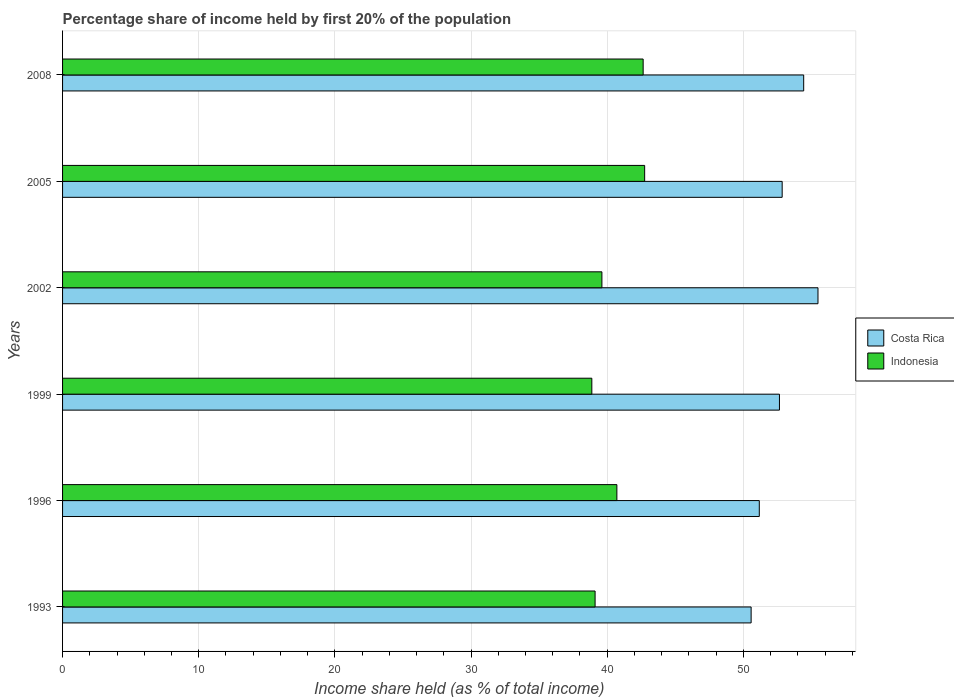How many groups of bars are there?
Provide a succinct answer. 6. Are the number of bars per tick equal to the number of legend labels?
Offer a very short reply. Yes. Are the number of bars on each tick of the Y-axis equal?
Make the answer very short. Yes. What is the label of the 6th group of bars from the top?
Your answer should be very brief. 1993. What is the share of income held by first 20% of the population in Indonesia in 1999?
Offer a very short reply. 38.87. Across all years, what is the maximum share of income held by first 20% of the population in Indonesia?
Ensure brevity in your answer.  42.75. Across all years, what is the minimum share of income held by first 20% of the population in Indonesia?
Offer a terse response. 38.87. In which year was the share of income held by first 20% of the population in Indonesia maximum?
Provide a short and direct response. 2005. In which year was the share of income held by first 20% of the population in Costa Rica minimum?
Keep it short and to the point. 1993. What is the total share of income held by first 20% of the population in Costa Rica in the graph?
Provide a short and direct response. 317.15. What is the difference between the share of income held by first 20% of the population in Indonesia in 1993 and that in 2005?
Ensure brevity in your answer.  -3.64. What is the difference between the share of income held by first 20% of the population in Indonesia in 2008 and the share of income held by first 20% of the population in Costa Rica in 1999?
Provide a succinct answer. -10.01. What is the average share of income held by first 20% of the population in Indonesia per year?
Your response must be concise. 40.62. In the year 1999, what is the difference between the share of income held by first 20% of the population in Indonesia and share of income held by first 20% of the population in Costa Rica?
Ensure brevity in your answer.  -13.78. In how many years, is the share of income held by first 20% of the population in Indonesia greater than 16 %?
Provide a succinct answer. 6. What is the ratio of the share of income held by first 20% of the population in Costa Rica in 1993 to that in 2005?
Offer a terse response. 0.96. Is the share of income held by first 20% of the population in Costa Rica in 2002 less than that in 2005?
Your answer should be compact. No. Is the difference between the share of income held by first 20% of the population in Indonesia in 1999 and 2002 greater than the difference between the share of income held by first 20% of the population in Costa Rica in 1999 and 2002?
Ensure brevity in your answer.  Yes. What is the difference between the highest and the second highest share of income held by first 20% of the population in Indonesia?
Give a very brief answer. 0.11. What is the difference between the highest and the lowest share of income held by first 20% of the population in Costa Rica?
Ensure brevity in your answer.  4.91. What does the 2nd bar from the bottom in 2005 represents?
Provide a short and direct response. Indonesia. How many bars are there?
Offer a very short reply. 12. Are all the bars in the graph horizontal?
Your response must be concise. Yes. Does the graph contain any zero values?
Make the answer very short. No. Does the graph contain grids?
Your response must be concise. Yes. How many legend labels are there?
Make the answer very short. 2. What is the title of the graph?
Offer a terse response. Percentage share of income held by first 20% of the population. Does "Azerbaijan" appear as one of the legend labels in the graph?
Keep it short and to the point. No. What is the label or title of the X-axis?
Keep it short and to the point. Income share held (as % of total income). What is the label or title of the Y-axis?
Offer a terse response. Years. What is the Income share held (as % of total income) in Costa Rica in 1993?
Your response must be concise. 50.57. What is the Income share held (as % of total income) of Indonesia in 1993?
Give a very brief answer. 39.11. What is the Income share held (as % of total income) in Costa Rica in 1996?
Your answer should be very brief. 51.17. What is the Income share held (as % of total income) of Indonesia in 1996?
Your answer should be very brief. 40.71. What is the Income share held (as % of total income) in Costa Rica in 1999?
Your answer should be very brief. 52.65. What is the Income share held (as % of total income) in Indonesia in 1999?
Your answer should be compact. 38.87. What is the Income share held (as % of total income) in Costa Rica in 2002?
Your response must be concise. 55.48. What is the Income share held (as % of total income) of Indonesia in 2002?
Ensure brevity in your answer.  39.61. What is the Income share held (as % of total income) of Costa Rica in 2005?
Make the answer very short. 52.85. What is the Income share held (as % of total income) in Indonesia in 2005?
Your response must be concise. 42.75. What is the Income share held (as % of total income) of Costa Rica in 2008?
Give a very brief answer. 54.43. What is the Income share held (as % of total income) of Indonesia in 2008?
Offer a very short reply. 42.64. Across all years, what is the maximum Income share held (as % of total income) of Costa Rica?
Make the answer very short. 55.48. Across all years, what is the maximum Income share held (as % of total income) in Indonesia?
Your response must be concise. 42.75. Across all years, what is the minimum Income share held (as % of total income) in Costa Rica?
Your answer should be compact. 50.57. Across all years, what is the minimum Income share held (as % of total income) of Indonesia?
Keep it short and to the point. 38.87. What is the total Income share held (as % of total income) of Costa Rica in the graph?
Give a very brief answer. 317.15. What is the total Income share held (as % of total income) in Indonesia in the graph?
Provide a short and direct response. 243.69. What is the difference between the Income share held (as % of total income) in Costa Rica in 1993 and that in 1996?
Your response must be concise. -0.6. What is the difference between the Income share held (as % of total income) in Costa Rica in 1993 and that in 1999?
Offer a terse response. -2.08. What is the difference between the Income share held (as % of total income) of Indonesia in 1993 and that in 1999?
Give a very brief answer. 0.24. What is the difference between the Income share held (as % of total income) in Costa Rica in 1993 and that in 2002?
Give a very brief answer. -4.91. What is the difference between the Income share held (as % of total income) in Indonesia in 1993 and that in 2002?
Give a very brief answer. -0.5. What is the difference between the Income share held (as % of total income) of Costa Rica in 1993 and that in 2005?
Ensure brevity in your answer.  -2.28. What is the difference between the Income share held (as % of total income) in Indonesia in 1993 and that in 2005?
Your answer should be very brief. -3.64. What is the difference between the Income share held (as % of total income) in Costa Rica in 1993 and that in 2008?
Make the answer very short. -3.86. What is the difference between the Income share held (as % of total income) of Indonesia in 1993 and that in 2008?
Provide a short and direct response. -3.53. What is the difference between the Income share held (as % of total income) in Costa Rica in 1996 and that in 1999?
Provide a short and direct response. -1.48. What is the difference between the Income share held (as % of total income) of Indonesia in 1996 and that in 1999?
Your response must be concise. 1.84. What is the difference between the Income share held (as % of total income) in Costa Rica in 1996 and that in 2002?
Give a very brief answer. -4.31. What is the difference between the Income share held (as % of total income) in Costa Rica in 1996 and that in 2005?
Provide a short and direct response. -1.68. What is the difference between the Income share held (as % of total income) of Indonesia in 1996 and that in 2005?
Ensure brevity in your answer.  -2.04. What is the difference between the Income share held (as % of total income) of Costa Rica in 1996 and that in 2008?
Give a very brief answer. -3.26. What is the difference between the Income share held (as % of total income) of Indonesia in 1996 and that in 2008?
Offer a terse response. -1.93. What is the difference between the Income share held (as % of total income) in Costa Rica in 1999 and that in 2002?
Your response must be concise. -2.83. What is the difference between the Income share held (as % of total income) of Indonesia in 1999 and that in 2002?
Offer a very short reply. -0.74. What is the difference between the Income share held (as % of total income) of Costa Rica in 1999 and that in 2005?
Make the answer very short. -0.2. What is the difference between the Income share held (as % of total income) in Indonesia in 1999 and that in 2005?
Make the answer very short. -3.88. What is the difference between the Income share held (as % of total income) of Costa Rica in 1999 and that in 2008?
Offer a very short reply. -1.78. What is the difference between the Income share held (as % of total income) of Indonesia in 1999 and that in 2008?
Give a very brief answer. -3.77. What is the difference between the Income share held (as % of total income) of Costa Rica in 2002 and that in 2005?
Give a very brief answer. 2.63. What is the difference between the Income share held (as % of total income) of Indonesia in 2002 and that in 2005?
Give a very brief answer. -3.14. What is the difference between the Income share held (as % of total income) in Costa Rica in 2002 and that in 2008?
Ensure brevity in your answer.  1.05. What is the difference between the Income share held (as % of total income) in Indonesia in 2002 and that in 2008?
Your answer should be compact. -3.03. What is the difference between the Income share held (as % of total income) of Costa Rica in 2005 and that in 2008?
Provide a succinct answer. -1.58. What is the difference between the Income share held (as % of total income) of Indonesia in 2005 and that in 2008?
Make the answer very short. 0.11. What is the difference between the Income share held (as % of total income) in Costa Rica in 1993 and the Income share held (as % of total income) in Indonesia in 1996?
Your response must be concise. 9.86. What is the difference between the Income share held (as % of total income) in Costa Rica in 1993 and the Income share held (as % of total income) in Indonesia in 2002?
Your answer should be compact. 10.96. What is the difference between the Income share held (as % of total income) in Costa Rica in 1993 and the Income share held (as % of total income) in Indonesia in 2005?
Your response must be concise. 7.82. What is the difference between the Income share held (as % of total income) in Costa Rica in 1993 and the Income share held (as % of total income) in Indonesia in 2008?
Provide a short and direct response. 7.93. What is the difference between the Income share held (as % of total income) of Costa Rica in 1996 and the Income share held (as % of total income) of Indonesia in 1999?
Keep it short and to the point. 12.3. What is the difference between the Income share held (as % of total income) of Costa Rica in 1996 and the Income share held (as % of total income) of Indonesia in 2002?
Make the answer very short. 11.56. What is the difference between the Income share held (as % of total income) of Costa Rica in 1996 and the Income share held (as % of total income) of Indonesia in 2005?
Make the answer very short. 8.42. What is the difference between the Income share held (as % of total income) in Costa Rica in 1996 and the Income share held (as % of total income) in Indonesia in 2008?
Your answer should be compact. 8.53. What is the difference between the Income share held (as % of total income) in Costa Rica in 1999 and the Income share held (as % of total income) in Indonesia in 2002?
Provide a succinct answer. 13.04. What is the difference between the Income share held (as % of total income) in Costa Rica in 1999 and the Income share held (as % of total income) in Indonesia in 2005?
Make the answer very short. 9.9. What is the difference between the Income share held (as % of total income) of Costa Rica in 1999 and the Income share held (as % of total income) of Indonesia in 2008?
Offer a terse response. 10.01. What is the difference between the Income share held (as % of total income) of Costa Rica in 2002 and the Income share held (as % of total income) of Indonesia in 2005?
Offer a very short reply. 12.73. What is the difference between the Income share held (as % of total income) in Costa Rica in 2002 and the Income share held (as % of total income) in Indonesia in 2008?
Keep it short and to the point. 12.84. What is the difference between the Income share held (as % of total income) of Costa Rica in 2005 and the Income share held (as % of total income) of Indonesia in 2008?
Keep it short and to the point. 10.21. What is the average Income share held (as % of total income) of Costa Rica per year?
Your response must be concise. 52.86. What is the average Income share held (as % of total income) of Indonesia per year?
Your response must be concise. 40.62. In the year 1993, what is the difference between the Income share held (as % of total income) of Costa Rica and Income share held (as % of total income) of Indonesia?
Your answer should be compact. 11.46. In the year 1996, what is the difference between the Income share held (as % of total income) in Costa Rica and Income share held (as % of total income) in Indonesia?
Offer a terse response. 10.46. In the year 1999, what is the difference between the Income share held (as % of total income) of Costa Rica and Income share held (as % of total income) of Indonesia?
Give a very brief answer. 13.78. In the year 2002, what is the difference between the Income share held (as % of total income) in Costa Rica and Income share held (as % of total income) in Indonesia?
Provide a short and direct response. 15.87. In the year 2005, what is the difference between the Income share held (as % of total income) of Costa Rica and Income share held (as % of total income) of Indonesia?
Give a very brief answer. 10.1. In the year 2008, what is the difference between the Income share held (as % of total income) in Costa Rica and Income share held (as % of total income) in Indonesia?
Give a very brief answer. 11.79. What is the ratio of the Income share held (as % of total income) of Costa Rica in 1993 to that in 1996?
Your answer should be very brief. 0.99. What is the ratio of the Income share held (as % of total income) in Indonesia in 1993 to that in 1996?
Your answer should be very brief. 0.96. What is the ratio of the Income share held (as % of total income) of Costa Rica in 1993 to that in 1999?
Provide a succinct answer. 0.96. What is the ratio of the Income share held (as % of total income) of Indonesia in 1993 to that in 1999?
Offer a very short reply. 1.01. What is the ratio of the Income share held (as % of total income) of Costa Rica in 1993 to that in 2002?
Offer a terse response. 0.91. What is the ratio of the Income share held (as % of total income) of Indonesia in 1993 to that in 2002?
Offer a terse response. 0.99. What is the ratio of the Income share held (as % of total income) of Costa Rica in 1993 to that in 2005?
Provide a short and direct response. 0.96. What is the ratio of the Income share held (as % of total income) of Indonesia in 1993 to that in 2005?
Your answer should be compact. 0.91. What is the ratio of the Income share held (as % of total income) in Costa Rica in 1993 to that in 2008?
Your answer should be very brief. 0.93. What is the ratio of the Income share held (as % of total income) of Indonesia in 1993 to that in 2008?
Make the answer very short. 0.92. What is the ratio of the Income share held (as % of total income) of Costa Rica in 1996 to that in 1999?
Provide a short and direct response. 0.97. What is the ratio of the Income share held (as % of total income) in Indonesia in 1996 to that in 1999?
Provide a short and direct response. 1.05. What is the ratio of the Income share held (as % of total income) of Costa Rica in 1996 to that in 2002?
Make the answer very short. 0.92. What is the ratio of the Income share held (as % of total income) of Indonesia in 1996 to that in 2002?
Provide a short and direct response. 1.03. What is the ratio of the Income share held (as % of total income) in Costa Rica in 1996 to that in 2005?
Provide a succinct answer. 0.97. What is the ratio of the Income share held (as % of total income) in Indonesia in 1996 to that in 2005?
Provide a succinct answer. 0.95. What is the ratio of the Income share held (as % of total income) of Costa Rica in 1996 to that in 2008?
Your answer should be very brief. 0.94. What is the ratio of the Income share held (as % of total income) in Indonesia in 1996 to that in 2008?
Provide a succinct answer. 0.95. What is the ratio of the Income share held (as % of total income) of Costa Rica in 1999 to that in 2002?
Offer a very short reply. 0.95. What is the ratio of the Income share held (as % of total income) in Indonesia in 1999 to that in 2002?
Your response must be concise. 0.98. What is the ratio of the Income share held (as % of total income) in Costa Rica in 1999 to that in 2005?
Your answer should be compact. 1. What is the ratio of the Income share held (as % of total income) of Indonesia in 1999 to that in 2005?
Provide a short and direct response. 0.91. What is the ratio of the Income share held (as % of total income) of Costa Rica in 1999 to that in 2008?
Offer a terse response. 0.97. What is the ratio of the Income share held (as % of total income) in Indonesia in 1999 to that in 2008?
Provide a succinct answer. 0.91. What is the ratio of the Income share held (as % of total income) in Costa Rica in 2002 to that in 2005?
Provide a succinct answer. 1.05. What is the ratio of the Income share held (as % of total income) of Indonesia in 2002 to that in 2005?
Keep it short and to the point. 0.93. What is the ratio of the Income share held (as % of total income) of Costa Rica in 2002 to that in 2008?
Provide a succinct answer. 1.02. What is the ratio of the Income share held (as % of total income) of Indonesia in 2002 to that in 2008?
Your answer should be compact. 0.93. What is the ratio of the Income share held (as % of total income) of Costa Rica in 2005 to that in 2008?
Your answer should be very brief. 0.97. What is the ratio of the Income share held (as % of total income) in Indonesia in 2005 to that in 2008?
Your answer should be compact. 1. What is the difference between the highest and the second highest Income share held (as % of total income) of Indonesia?
Keep it short and to the point. 0.11. What is the difference between the highest and the lowest Income share held (as % of total income) in Costa Rica?
Offer a terse response. 4.91. What is the difference between the highest and the lowest Income share held (as % of total income) of Indonesia?
Your answer should be compact. 3.88. 